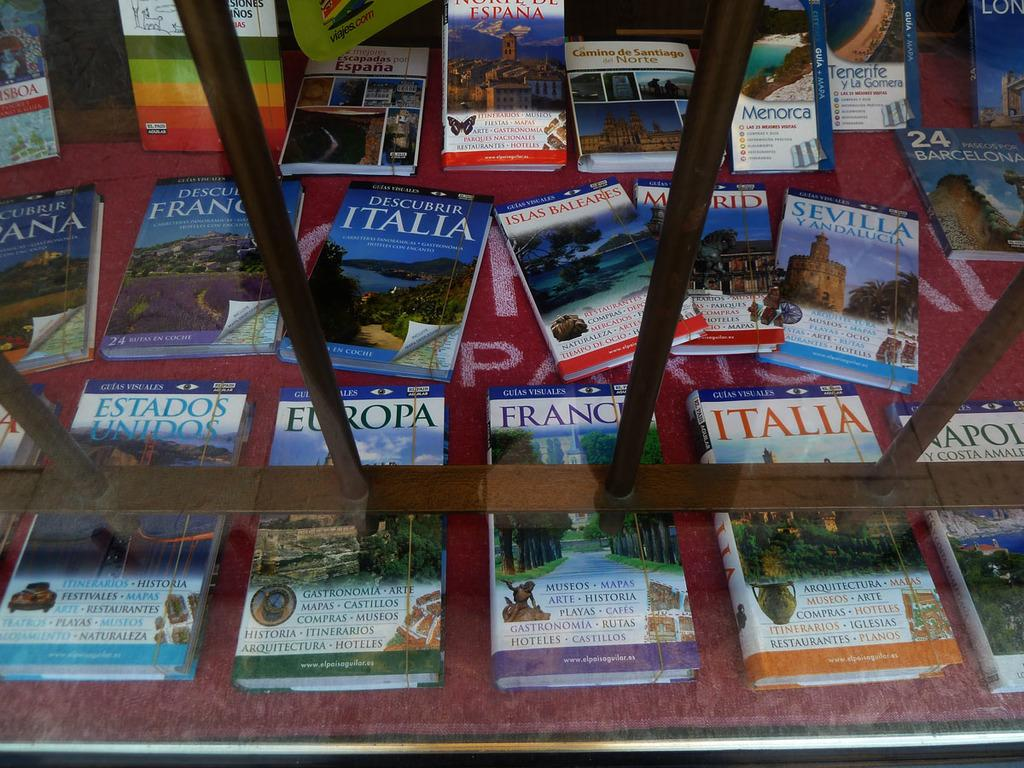<image>
Create a compact narrative representing the image presented. books about italia and france are shown about 